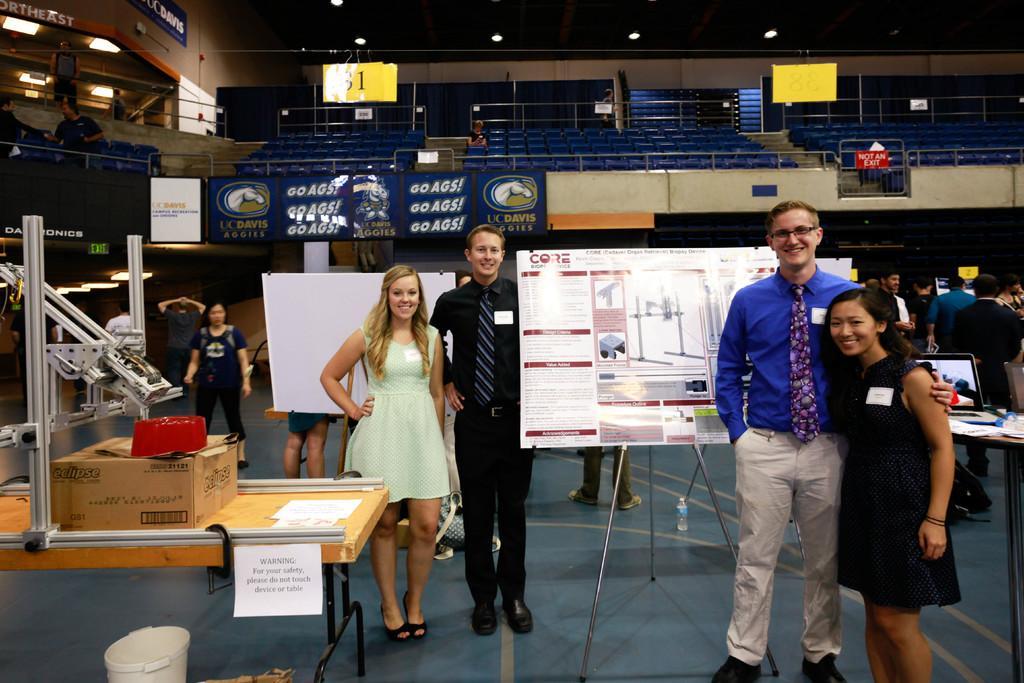Could you give a brief overview of what you see in this image? There are four persons standing on the floor and posing to a camera. Here we can see a tables, box, posters, boards, and group of people. In the background we can see hoardings, chairs, lights, and a wall. 